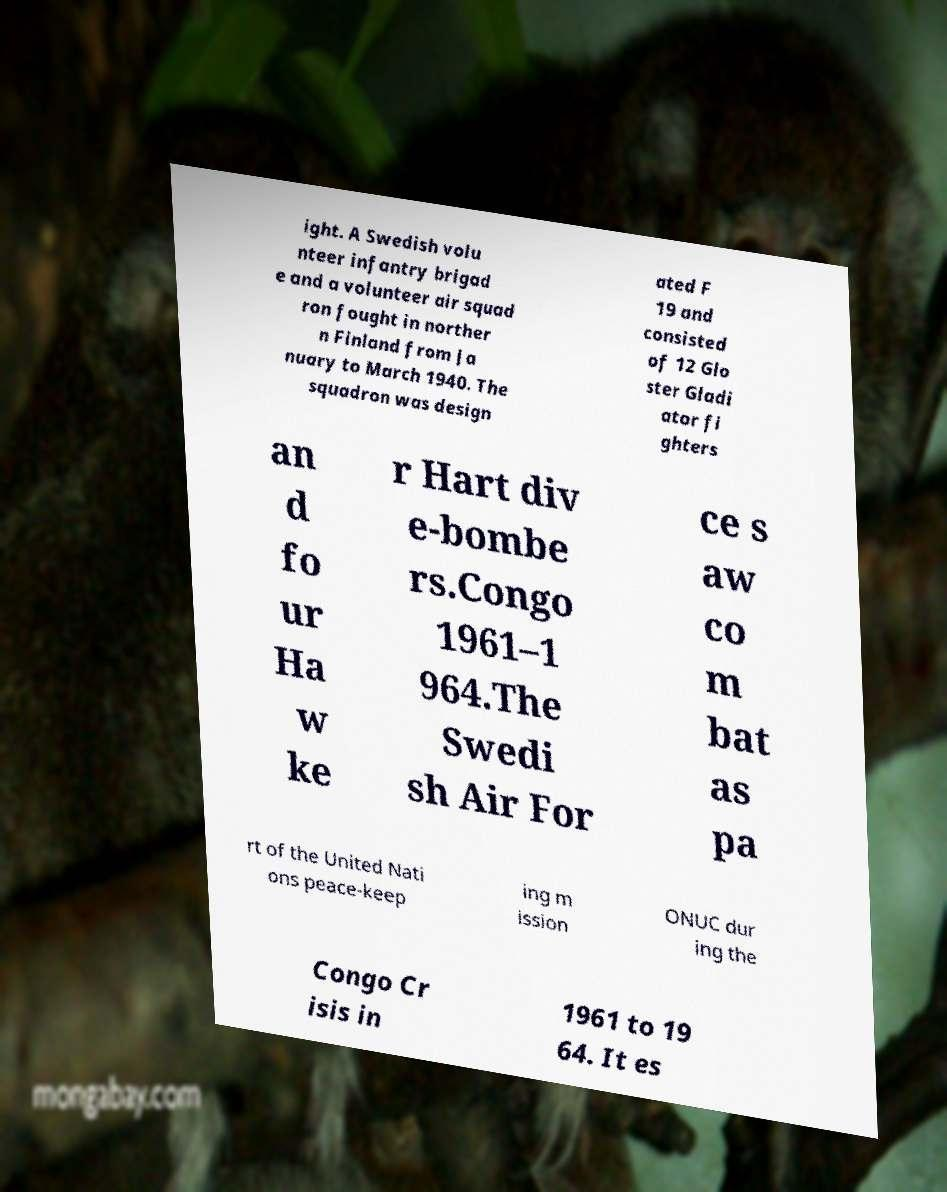What messages or text are displayed in this image? I need them in a readable, typed format. ight. A Swedish volu nteer infantry brigad e and a volunteer air squad ron fought in norther n Finland from Ja nuary to March 1940. The squadron was design ated F 19 and consisted of 12 Glo ster Gladi ator fi ghters an d fo ur Ha w ke r Hart div e-bombe rs.Congo 1961–1 964.The Swedi sh Air For ce s aw co m bat as pa rt of the United Nati ons peace-keep ing m ission ONUC dur ing the Congo Cr isis in 1961 to 19 64. It es 